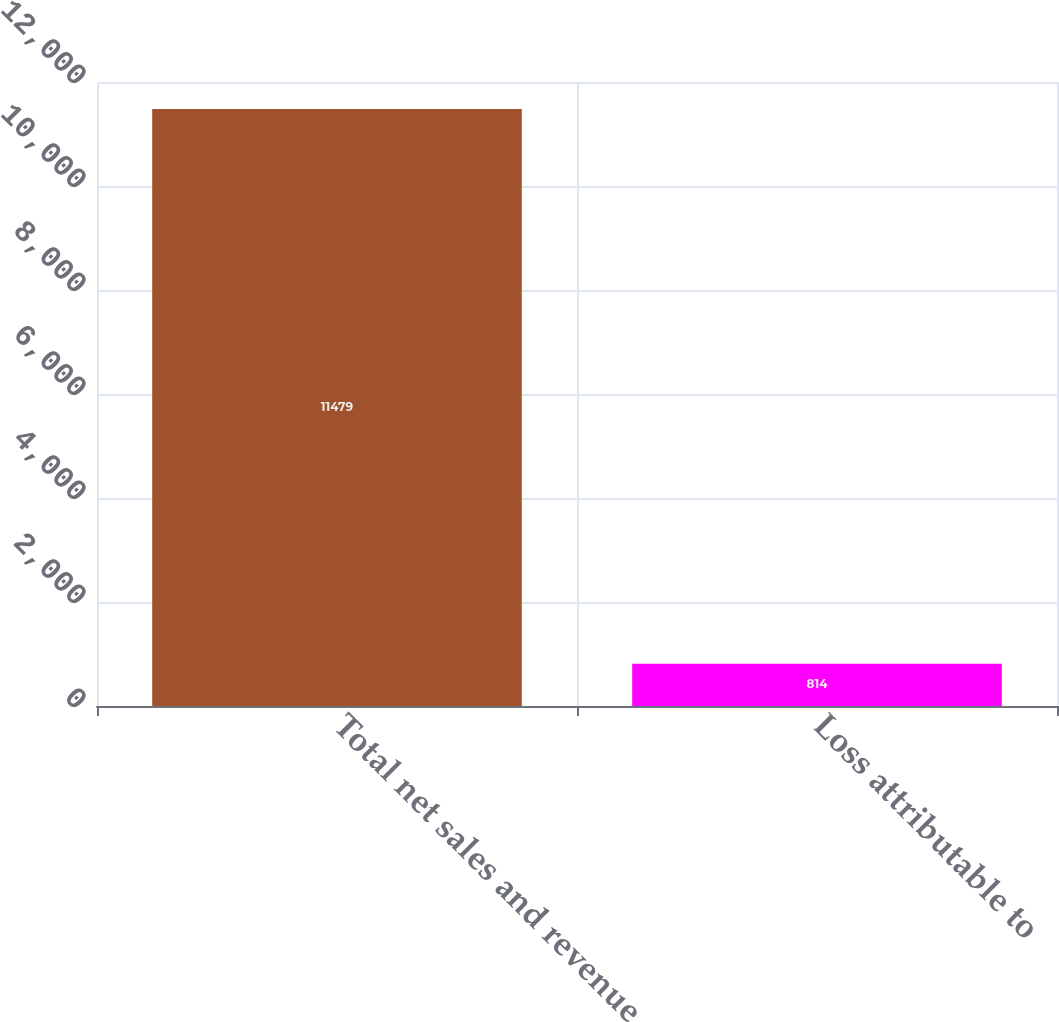Convert chart to OTSL. <chart><loc_0><loc_0><loc_500><loc_500><bar_chart><fcel>Total net sales and revenue<fcel>Loss attributable to<nl><fcel>11479<fcel>814<nl></chart> 